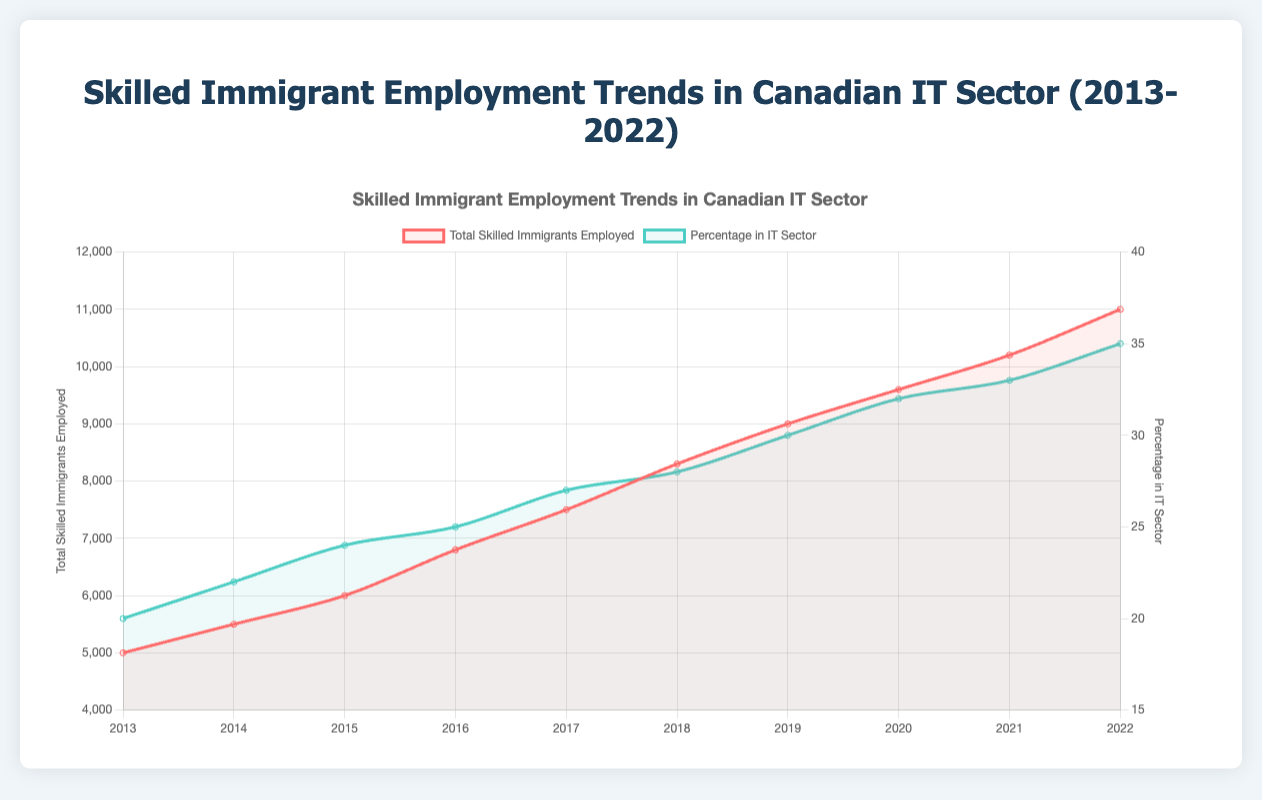What is the total change in the number of skilled immigrants employed in the IT sector from 2013 to 2022? The number of skilled immigrants employed in the IT sector in 2013 is 5000, and in 2022 it is 11000. The total change can be calculated by subtracting the initial value from the final value: 11000 - 5000 = 6000
Answer: 6000 Which year saw the highest percentage of skilled immigrants employed in the IT sector? According to the figure, each year's percentage of skilled immigrants employed in the IT sector is represented clearly. The year with the highest percentage is 2022 with 35%
Answer: 2022 Compare the percentage of skilled immigrants employed in the IT sector in 2016 and 2020. Which year had a higher percentage and by how much? In 2016, the percentage was 25%, and in 2020, it was 32%. To find the difference, subtract the 2016 value from the 2020 value: 32% - 25% = 7%. Thus, 2020 had a higher percentage by 7%
Answer: 2020, by 7% What is the average percentage of skilled immigrants employed in the IT sector from 2013 to 2022? First, find the sum of the percentages from 2013 to 2022: 20 + 22 + 24 + 25 + 27 + 28 + 30 + 32 + 33 + 35 = 276. There are 10 years in total, so the average is 276 / 10 = 27.6%
Answer: 27.6% Between which consecutive years did the total skilled immigrants employed in the IT sector see the largest increase? To find this, calculate the increase for each pair of consecutive years and compare them: 2014-2013 (5500-5000 = 500), 2015-2014 (6000-5500 = 500), 2016-2015 (6800-6000 = 800), 2017-2016 (7500-6800 = 700), 2018-2017 (8300-7500 = 800), 2019-2018 (9000-8300 = 700), 2020-2019 (9600-9000 = 600), 2021-2020 (10200-9600 = 600), 2022-2021 (11000-10200 = 800). The largest increase was 800 between both 2015-2016 and 2021-2022
Answer: 2015-2016 and 2021-2022 How many more skilled immigrants were employed in the IT sector in 2018 compared to 2013? In 2018, there were 8300 skilled immigrants employed compared to 5000 in 2013. The difference is 8300 - 5000 = 3300
Answer: 3300 What was the percentage increase in skilled immigrants employed in the IT sector from 2017 to 2018? In 2017, 27% of skilled immigrants were in the IT sector. In 2018, this increased to 28%. To find the percentage increase: (28 - 27) / 27 * 100 = 3.7%
Answer: 3.7% Identify one year within the decade where the top job titles included "Data Scientist" and describe its trend visualisation attribute in color. The top job titles included "Data Scientist" for the first time in 2017. The trend of this attribute is visualised using the color associated with the percentage in IT sector line, which is green. This color represents the integration of new roles reflecting evolving IT demands
Answer: 2017, green 